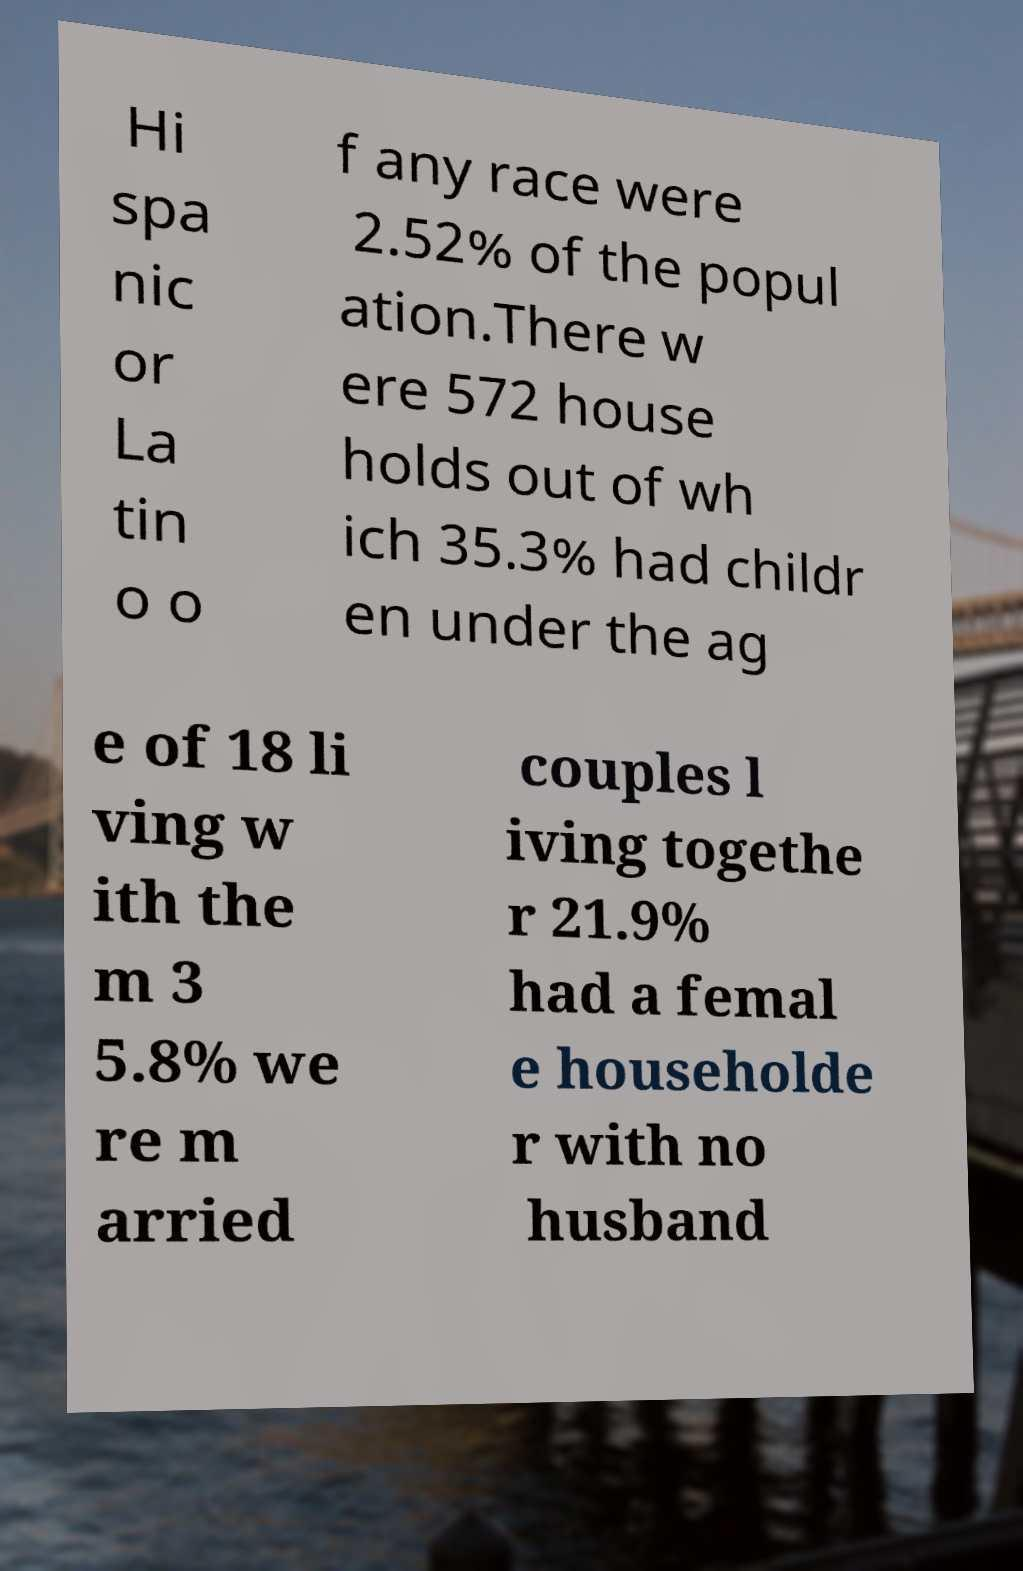For documentation purposes, I need the text within this image transcribed. Could you provide that? Hi spa nic or La tin o o f any race were 2.52% of the popul ation.There w ere 572 house holds out of wh ich 35.3% had childr en under the ag e of 18 li ving w ith the m 3 5.8% we re m arried couples l iving togethe r 21.9% had a femal e householde r with no husband 